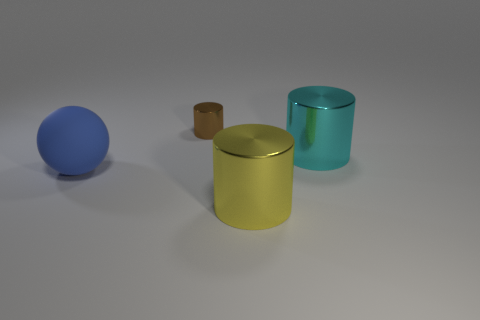Are there more small objects in front of the big blue matte object than small cyan spheres?
Keep it short and to the point. No. Is there any other thing of the same color as the tiny shiny cylinder?
Offer a very short reply. No. There is a large yellow thing that is the same material as the brown cylinder; what is its shape?
Ensure brevity in your answer.  Cylinder. Is the large cylinder behind the big yellow object made of the same material as the blue thing?
Ensure brevity in your answer.  No. Do the thing that is on the left side of the brown shiny object and the shiny cylinder that is in front of the cyan metallic cylinder have the same color?
Offer a very short reply. No. What number of objects are in front of the tiny brown metallic cylinder and to the right of the large blue matte ball?
Give a very brief answer. 2. What material is the small object?
Offer a very short reply. Metal. The other metal object that is the same size as the cyan object is what shape?
Give a very brief answer. Cylinder. Are the large object in front of the blue sphere and the cylinder that is behind the big cyan metallic object made of the same material?
Make the answer very short. Yes. What number of cyan cylinders are there?
Your answer should be compact. 1. 